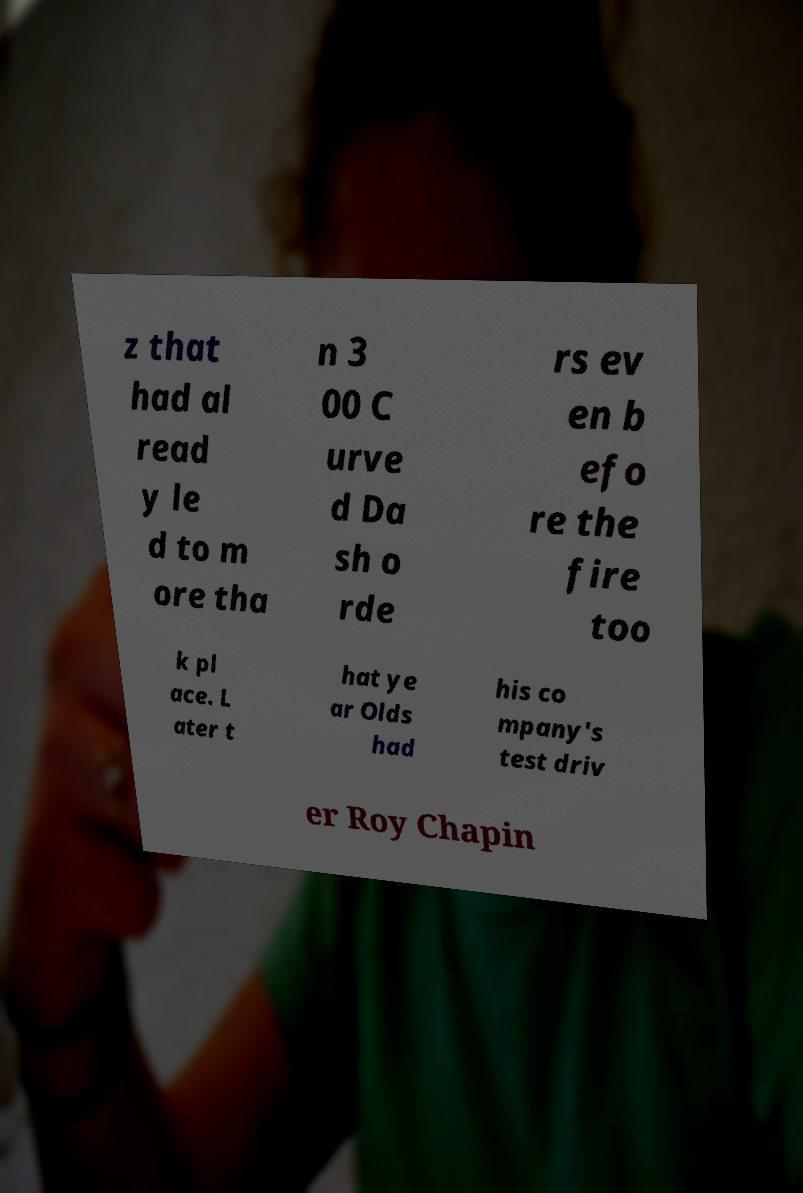What messages or text are displayed in this image? I need them in a readable, typed format. z that had al read y le d to m ore tha n 3 00 C urve d Da sh o rde rs ev en b efo re the fire too k pl ace. L ater t hat ye ar Olds had his co mpany's test driv er Roy Chapin 